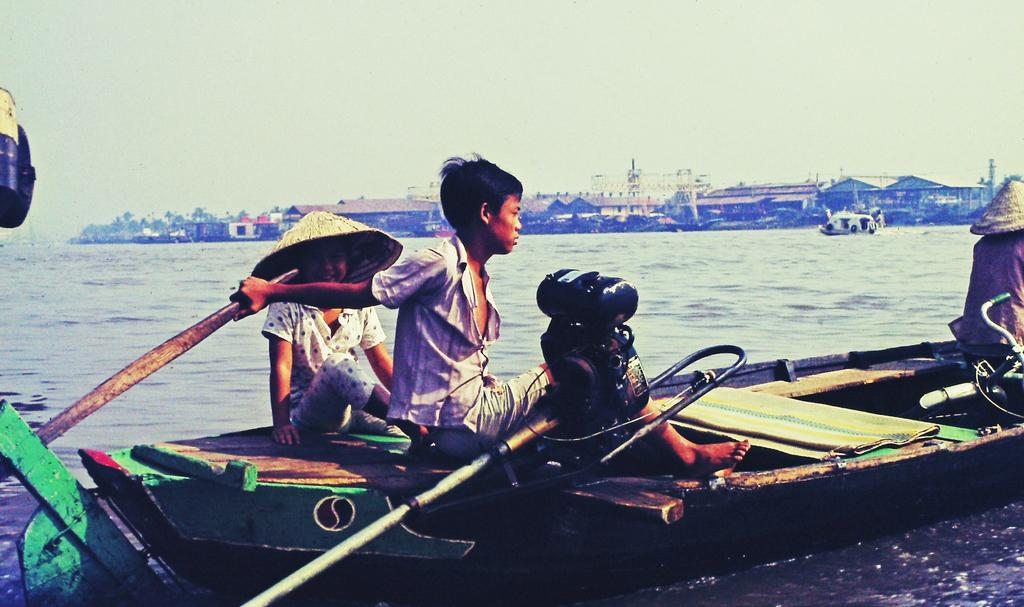How many people are in the image? There is a group of people in the image. What are the people doing in the image? The people are sitting in a boat. Where is the boat located in the image? The boat is on the water. What can be seen in the background of the image? There are houses in the background of the image. What colors are the houses in the image? The houses are in white and brown colors. What is the color of the sky in the image? The sky is white in color. How is the lead being distributed among the trains in the image? There are no trains or lead present in the image; it features a group of people sitting in a boat on the water with houses and a white sky in the background. 